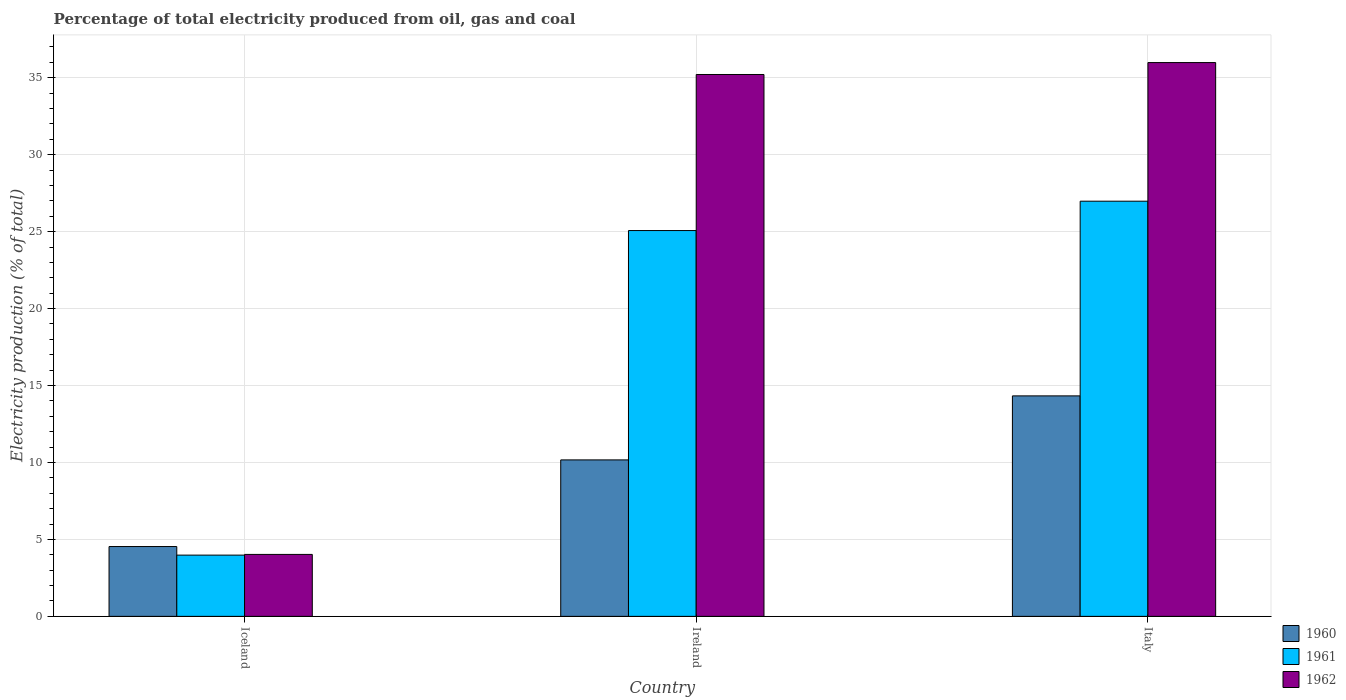How many different coloured bars are there?
Your answer should be compact. 3. Are the number of bars on each tick of the X-axis equal?
Ensure brevity in your answer.  Yes. How many bars are there on the 2nd tick from the right?
Your response must be concise. 3. What is the label of the 1st group of bars from the left?
Provide a succinct answer. Iceland. In how many cases, is the number of bars for a given country not equal to the number of legend labels?
Make the answer very short. 0. What is the electricity production in in 1960 in Italy?
Offer a terse response. 14.33. Across all countries, what is the maximum electricity production in in 1961?
Provide a succinct answer. 26.98. Across all countries, what is the minimum electricity production in in 1961?
Provide a succinct answer. 3.98. What is the total electricity production in in 1960 in the graph?
Provide a succinct answer. 29.03. What is the difference between the electricity production in in 1961 in Iceland and that in Ireland?
Your response must be concise. -21.09. What is the difference between the electricity production in in 1961 in Iceland and the electricity production in in 1962 in Italy?
Provide a succinct answer. -32.01. What is the average electricity production in in 1960 per country?
Ensure brevity in your answer.  9.68. What is the difference between the electricity production in of/in 1960 and electricity production in of/in 1961 in Italy?
Your answer should be very brief. -12.65. In how many countries, is the electricity production in in 1962 greater than 28 %?
Ensure brevity in your answer.  2. What is the ratio of the electricity production in in 1960 in Iceland to that in Ireland?
Make the answer very short. 0.45. Is the difference between the electricity production in in 1960 in Iceland and Ireland greater than the difference between the electricity production in in 1961 in Iceland and Ireland?
Make the answer very short. Yes. What is the difference between the highest and the second highest electricity production in in 1962?
Offer a very short reply. -0.78. What is the difference between the highest and the lowest electricity production in in 1960?
Offer a very short reply. 9.79. In how many countries, is the electricity production in in 1962 greater than the average electricity production in in 1962 taken over all countries?
Provide a short and direct response. 2. What does the 2nd bar from the left in Ireland represents?
Give a very brief answer. 1961. How many bars are there?
Offer a very short reply. 9. Are all the bars in the graph horizontal?
Your response must be concise. No. What is the difference between two consecutive major ticks on the Y-axis?
Offer a terse response. 5. Where does the legend appear in the graph?
Keep it short and to the point. Bottom right. How are the legend labels stacked?
Offer a terse response. Vertical. What is the title of the graph?
Provide a short and direct response. Percentage of total electricity produced from oil, gas and coal. What is the label or title of the X-axis?
Make the answer very short. Country. What is the label or title of the Y-axis?
Give a very brief answer. Electricity production (% of total). What is the Electricity production (% of total) of 1960 in Iceland?
Make the answer very short. 4.54. What is the Electricity production (% of total) of 1961 in Iceland?
Your answer should be very brief. 3.98. What is the Electricity production (% of total) of 1962 in Iceland?
Provide a succinct answer. 4.03. What is the Electricity production (% of total) of 1960 in Ireland?
Give a very brief answer. 10.17. What is the Electricity production (% of total) in 1961 in Ireland?
Your answer should be very brief. 25.07. What is the Electricity production (% of total) in 1962 in Ireland?
Keep it short and to the point. 35.21. What is the Electricity production (% of total) in 1960 in Italy?
Give a very brief answer. 14.33. What is the Electricity production (% of total) of 1961 in Italy?
Your response must be concise. 26.98. What is the Electricity production (% of total) of 1962 in Italy?
Your answer should be compact. 35.99. Across all countries, what is the maximum Electricity production (% of total) of 1960?
Provide a short and direct response. 14.33. Across all countries, what is the maximum Electricity production (% of total) of 1961?
Keep it short and to the point. 26.98. Across all countries, what is the maximum Electricity production (% of total) of 1962?
Offer a terse response. 35.99. Across all countries, what is the minimum Electricity production (% of total) of 1960?
Offer a very short reply. 4.54. Across all countries, what is the minimum Electricity production (% of total) in 1961?
Ensure brevity in your answer.  3.98. Across all countries, what is the minimum Electricity production (% of total) of 1962?
Make the answer very short. 4.03. What is the total Electricity production (% of total) of 1960 in the graph?
Provide a succinct answer. 29.03. What is the total Electricity production (% of total) in 1961 in the graph?
Your response must be concise. 56.03. What is the total Electricity production (% of total) of 1962 in the graph?
Offer a very short reply. 75.22. What is the difference between the Electricity production (% of total) of 1960 in Iceland and that in Ireland?
Your answer should be compact. -5.63. What is the difference between the Electricity production (% of total) in 1961 in Iceland and that in Ireland?
Ensure brevity in your answer.  -21.09. What is the difference between the Electricity production (% of total) of 1962 in Iceland and that in Ireland?
Your response must be concise. -31.19. What is the difference between the Electricity production (% of total) of 1960 in Iceland and that in Italy?
Ensure brevity in your answer.  -9.79. What is the difference between the Electricity production (% of total) of 1961 in Iceland and that in Italy?
Provide a short and direct response. -23. What is the difference between the Electricity production (% of total) in 1962 in Iceland and that in Italy?
Make the answer very short. -31.96. What is the difference between the Electricity production (% of total) of 1960 in Ireland and that in Italy?
Your response must be concise. -4.16. What is the difference between the Electricity production (% of total) in 1961 in Ireland and that in Italy?
Your response must be concise. -1.91. What is the difference between the Electricity production (% of total) of 1962 in Ireland and that in Italy?
Your answer should be very brief. -0.78. What is the difference between the Electricity production (% of total) of 1960 in Iceland and the Electricity production (% of total) of 1961 in Ireland?
Ensure brevity in your answer.  -20.53. What is the difference between the Electricity production (% of total) of 1960 in Iceland and the Electricity production (% of total) of 1962 in Ireland?
Keep it short and to the point. -30.67. What is the difference between the Electricity production (% of total) in 1961 in Iceland and the Electricity production (% of total) in 1962 in Ireland?
Offer a terse response. -31.23. What is the difference between the Electricity production (% of total) of 1960 in Iceland and the Electricity production (% of total) of 1961 in Italy?
Offer a terse response. -22.44. What is the difference between the Electricity production (% of total) in 1960 in Iceland and the Electricity production (% of total) in 1962 in Italy?
Provide a short and direct response. -31.45. What is the difference between the Electricity production (% of total) in 1961 in Iceland and the Electricity production (% of total) in 1962 in Italy?
Ensure brevity in your answer.  -32.01. What is the difference between the Electricity production (% of total) of 1960 in Ireland and the Electricity production (% of total) of 1961 in Italy?
Your answer should be very brief. -16.81. What is the difference between the Electricity production (% of total) in 1960 in Ireland and the Electricity production (% of total) in 1962 in Italy?
Your answer should be very brief. -25.82. What is the difference between the Electricity production (% of total) of 1961 in Ireland and the Electricity production (% of total) of 1962 in Italy?
Keep it short and to the point. -10.92. What is the average Electricity production (% of total) of 1960 per country?
Your answer should be very brief. 9.68. What is the average Electricity production (% of total) of 1961 per country?
Your response must be concise. 18.68. What is the average Electricity production (% of total) of 1962 per country?
Provide a succinct answer. 25.07. What is the difference between the Electricity production (% of total) in 1960 and Electricity production (% of total) in 1961 in Iceland?
Offer a very short reply. 0.56. What is the difference between the Electricity production (% of total) of 1960 and Electricity production (% of total) of 1962 in Iceland?
Provide a succinct answer. 0.51. What is the difference between the Electricity production (% of total) of 1961 and Electricity production (% of total) of 1962 in Iceland?
Offer a terse response. -0.05. What is the difference between the Electricity production (% of total) in 1960 and Electricity production (% of total) in 1961 in Ireland?
Give a very brief answer. -14.9. What is the difference between the Electricity production (% of total) of 1960 and Electricity production (% of total) of 1962 in Ireland?
Your answer should be compact. -25.04. What is the difference between the Electricity production (% of total) of 1961 and Electricity production (% of total) of 1962 in Ireland?
Keep it short and to the point. -10.14. What is the difference between the Electricity production (% of total) in 1960 and Electricity production (% of total) in 1961 in Italy?
Your response must be concise. -12.65. What is the difference between the Electricity production (% of total) in 1960 and Electricity production (% of total) in 1962 in Italy?
Make the answer very short. -21.66. What is the difference between the Electricity production (% of total) in 1961 and Electricity production (% of total) in 1962 in Italy?
Provide a succinct answer. -9.01. What is the ratio of the Electricity production (% of total) in 1960 in Iceland to that in Ireland?
Make the answer very short. 0.45. What is the ratio of the Electricity production (% of total) in 1961 in Iceland to that in Ireland?
Keep it short and to the point. 0.16. What is the ratio of the Electricity production (% of total) of 1962 in Iceland to that in Ireland?
Give a very brief answer. 0.11. What is the ratio of the Electricity production (% of total) of 1960 in Iceland to that in Italy?
Provide a succinct answer. 0.32. What is the ratio of the Electricity production (% of total) in 1961 in Iceland to that in Italy?
Provide a succinct answer. 0.15. What is the ratio of the Electricity production (% of total) of 1962 in Iceland to that in Italy?
Provide a succinct answer. 0.11. What is the ratio of the Electricity production (% of total) of 1960 in Ireland to that in Italy?
Make the answer very short. 0.71. What is the ratio of the Electricity production (% of total) of 1961 in Ireland to that in Italy?
Ensure brevity in your answer.  0.93. What is the ratio of the Electricity production (% of total) in 1962 in Ireland to that in Italy?
Ensure brevity in your answer.  0.98. What is the difference between the highest and the second highest Electricity production (% of total) of 1960?
Provide a succinct answer. 4.16. What is the difference between the highest and the second highest Electricity production (% of total) of 1961?
Make the answer very short. 1.91. What is the difference between the highest and the second highest Electricity production (% of total) in 1962?
Your response must be concise. 0.78. What is the difference between the highest and the lowest Electricity production (% of total) in 1960?
Your response must be concise. 9.79. What is the difference between the highest and the lowest Electricity production (% of total) of 1961?
Keep it short and to the point. 23. What is the difference between the highest and the lowest Electricity production (% of total) in 1962?
Provide a short and direct response. 31.96. 